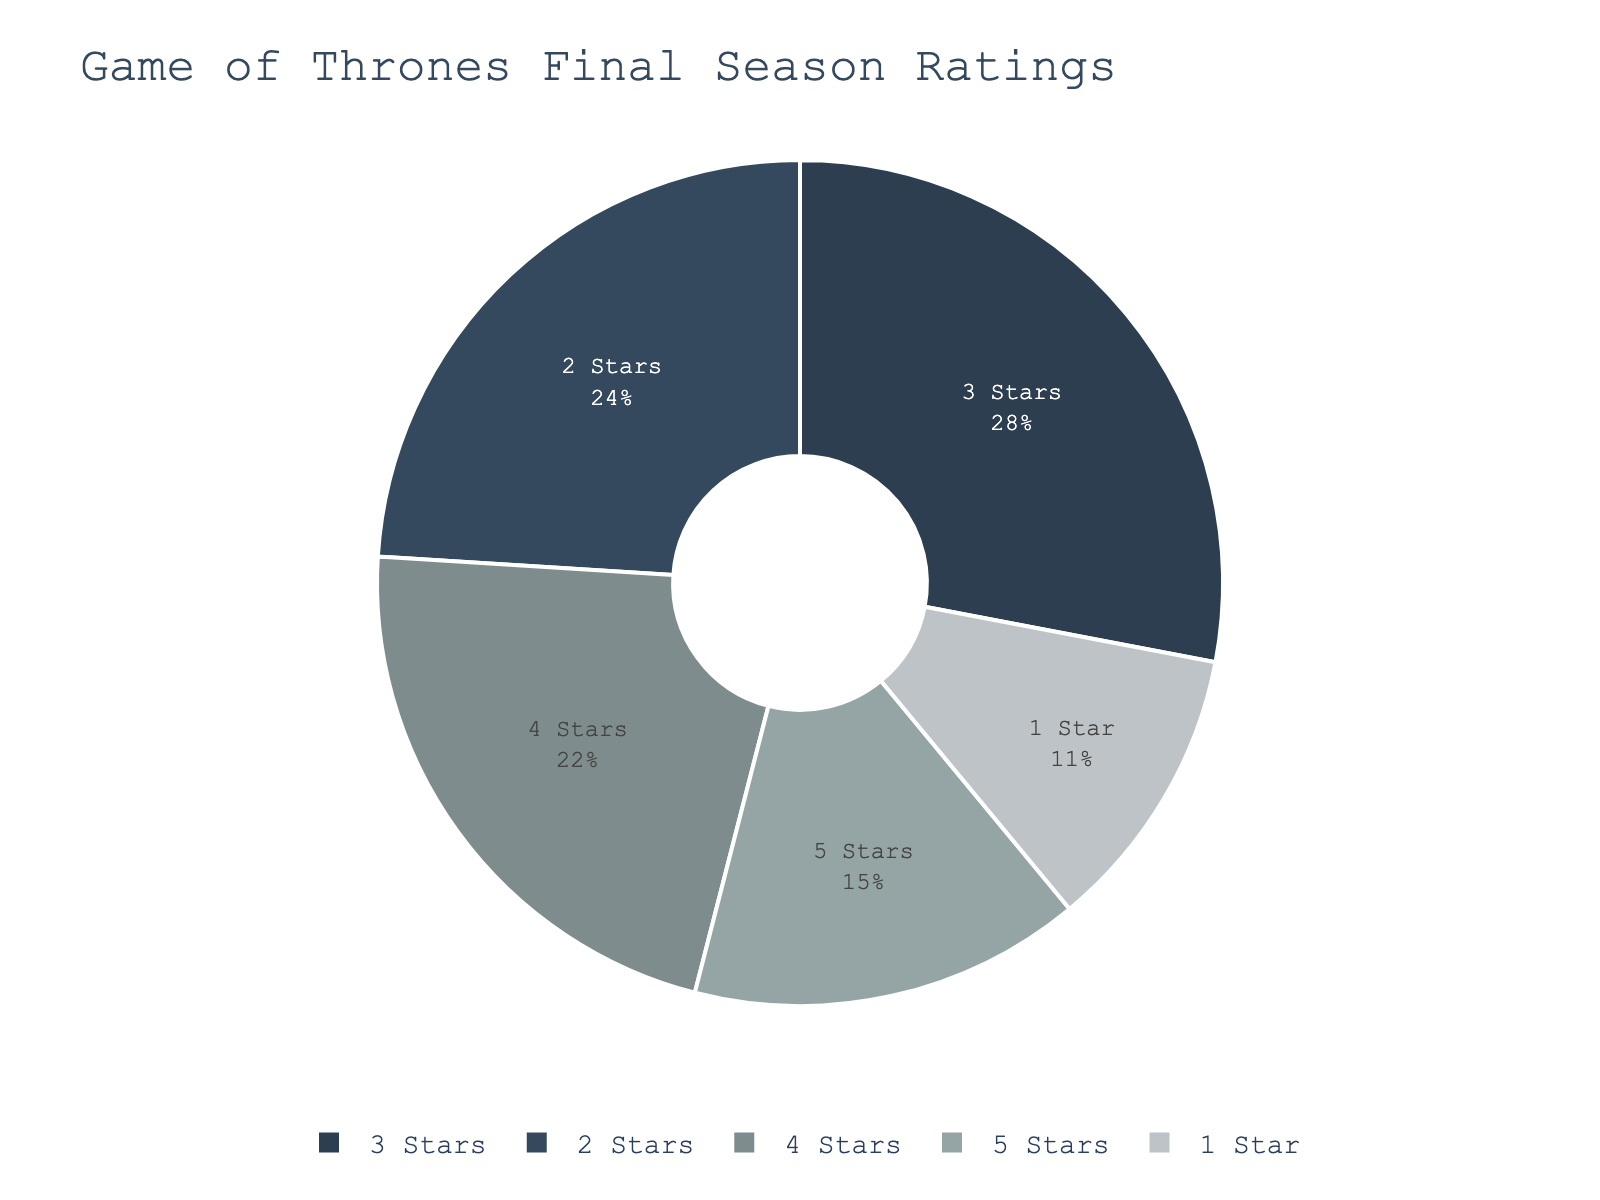What percentage of critical reviews gave a rating of 3 stars or more? To get the percentage of critical reviews that gave a rating of 3 stars or more, we need to sum up the percentages of the ratings for 3 stars, 4 stars, and 5 stars. That is 28% (3 stars) + 22% (4 stars) + 15% (5 stars) = 65%.
Answer: 65% Which rating received the highest percentage of reviews? By looking at the segments of the pie chart, the largest section corresponds to the 3-star rating, which is 28%.
Answer: 3 stars How does the percentage of 1-star reviews compare to 2-star reviews? The 1-star reviews have an 11% share, and the 2-star reviews have a 24% share. Therefore, the 2-star reviews are more than double the percentage of 1-star reviews (24% > 11%).
Answer: 2 stars received a higher percentage than 1 star What is the combined percentage of reviews that rated the final season below 3 stars? To determine the combined percentage of reviews that rated the final season below 3 stars, add the percentages of the 1-star and 2-star reviews: 11% + 24% = 35%.
Answer: 35% Are there more reviews that rated the final season 2 stars or 4 stars? The 2-star reviews have a percentage of 24%, and the 4-star reviews have a percentage of 22%. Therefore, there are more reviews that rated the final season 2 stars than 4 stars.
Answer: 2 stars What's the sum of percentages for all the reviews? By summing up all the individual percentages from the pie chart, we get 15% (5 stars) + 22% (4 stars) + 28% (3 stars) + 24% (2 stars) + 11% (1 star) = 100%.
Answer: 100% What is the least common rating? By visually inspecting the smallest section of the pie chart, we can see that the 1-star ratings have the smallest percentage at 11%.
Answer: 1 star How do the percentages of 5-star and 4-star ratings add up? The 5-star ratings have a percentage of 15%, and the 4-star ratings have a percentage of 22%. Adding these together gives 15% + 22% = 37%.
Answer: 37% What percentage of the reviews is below 4 stars but above 2 stars? The only rating that fits this criterion is the 3-star ratings. The percentage for 3-star reviews is 28%.
Answer: 28% If you were to group the ratings into "positive" (4 and 5 stars) and "negative" (1 and 2 stars), which group has a higher percentage, and by how much? Positive ratings are the sum of 4-star and 5-star ratings: 22% + 15% = 37%. Negative ratings are the sum of 1-star and 2-star ratings: 11% + 24% = 35%. The positive ratings are higher by 2% (37% - 35%).
Answer: Positive by 2% 